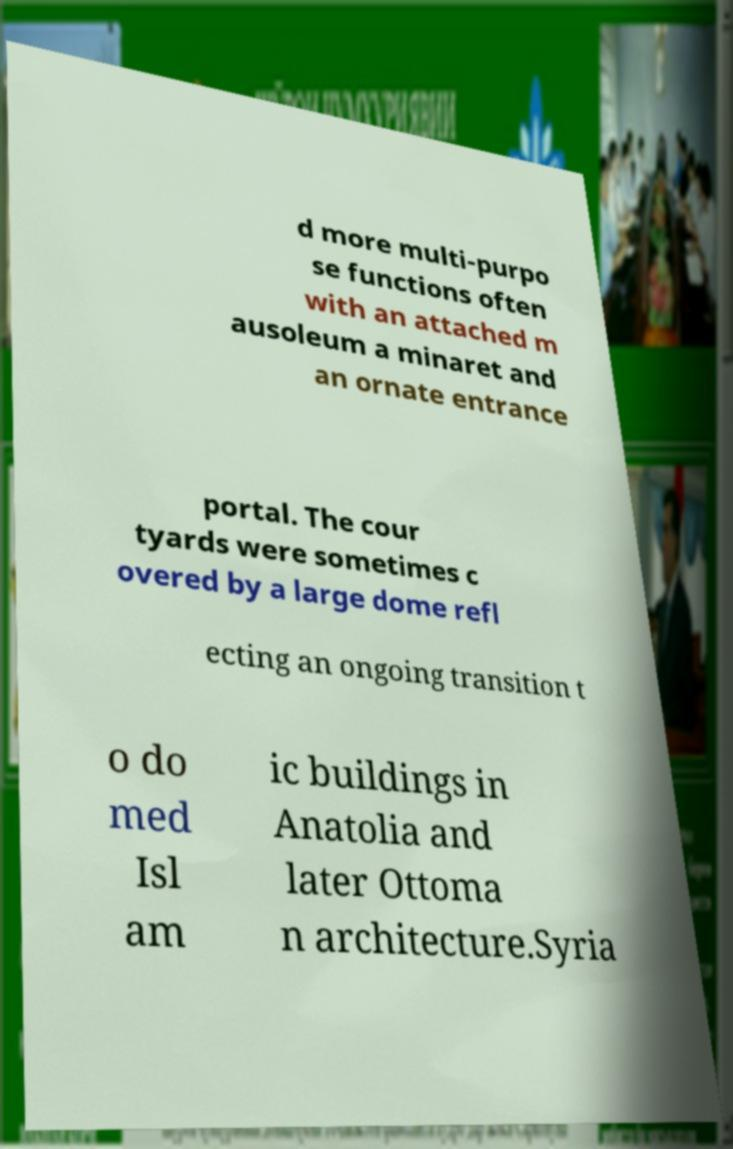Can you accurately transcribe the text from the provided image for me? d more multi-purpo se functions often with an attached m ausoleum a minaret and an ornate entrance portal. The cour tyards were sometimes c overed by a large dome refl ecting an ongoing transition t o do med Isl am ic buildings in Anatolia and later Ottoma n architecture.Syria 